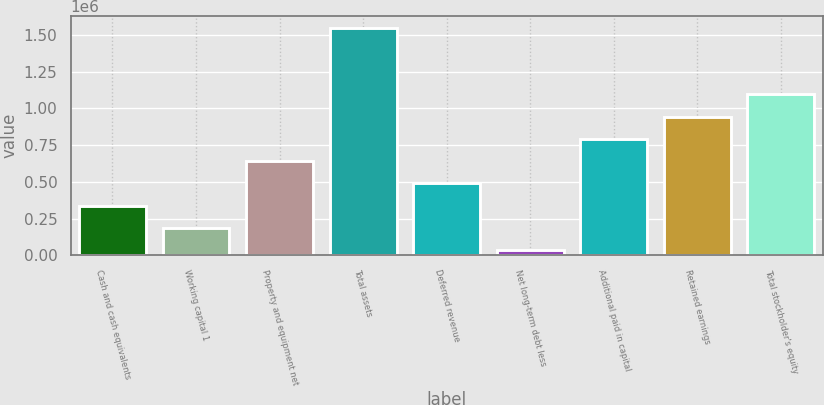Convert chart. <chart><loc_0><loc_0><loc_500><loc_500><bar_chart><fcel>Cash and cash equivalents<fcel>Working capital 1<fcel>Property and equipment net<fcel>Total assets<fcel>Deferred revenue<fcel>Net long-term debt less<fcel>Additional paid in capital<fcel>Retained earnings<fcel>Total stockholder's equity<nl><fcel>337559<fcel>185986<fcel>640704<fcel>1.55014e+06<fcel>489131<fcel>34414<fcel>792276<fcel>943848<fcel>1.09542e+06<nl></chart> 